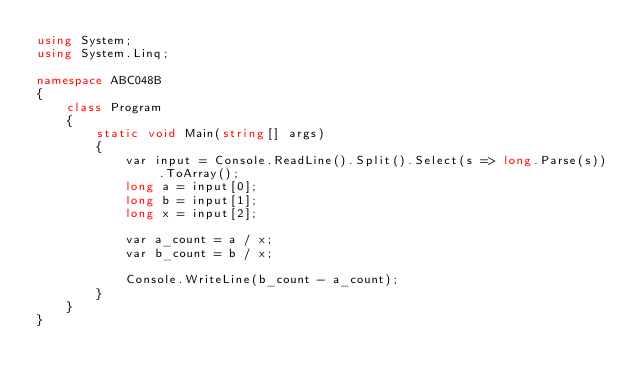Convert code to text. <code><loc_0><loc_0><loc_500><loc_500><_C#_>using System;
using System.Linq;

namespace ABC048B
{
    class Program
    {
        static void Main(string[] args)
        {
            var input = Console.ReadLine().Split().Select(s => long.Parse(s)).ToArray();
            long a = input[0];
            long b = input[1];
            long x = input[2];

            var a_count = a / x;
            var b_count = b / x;

            Console.WriteLine(b_count - a_count);
        }
    }
}
</code> 